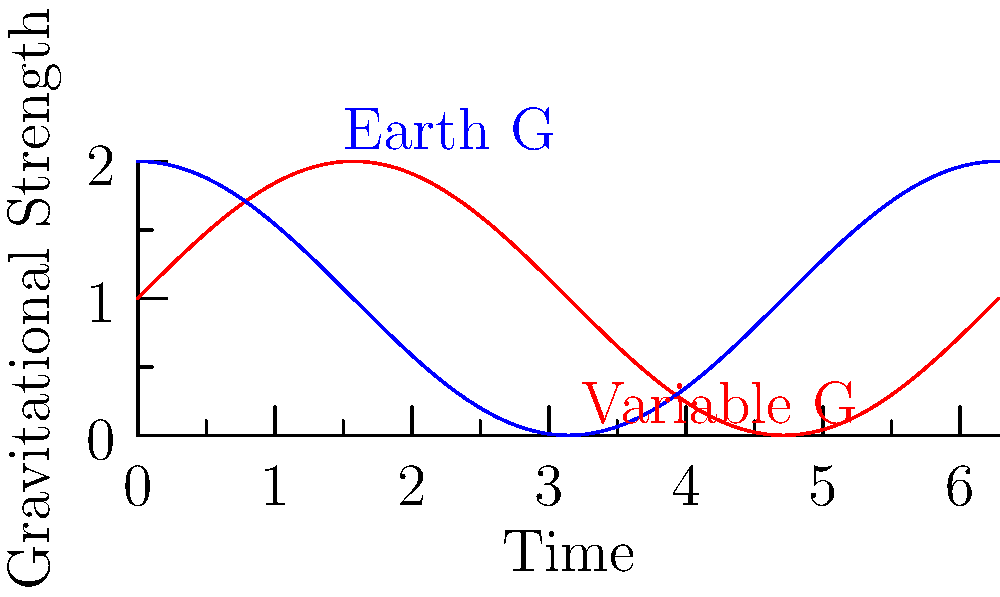In a time travel scenario, a scientist experiences varying gravitational fields as shown in the graph. How would the biomechanical adaptation of the time traveler's skeletal system differ between the variable G (red) and Earth G (blue) environments over time, and what potential issues might arise during the transition between these gravitational fields? 1. Gravitational variation: The red line shows a sinusoidal variation in gravitational strength, while the blue line represents constant Earth gravity.

2. Skeletal adaptation in variable G:
   a. Bone density: In periods of higher G, bone density would increase to withstand greater forces.
   b. Bone remodeling: Rapid changes in G would trigger accelerated bone remodeling.
   c. Muscle-bone interaction: Varying G would cause fluctuating muscle tension, affecting bone structure.

3. Skeletal adaptation in Earth G:
   a. Consistent bone density maintained.
   b. Normal bone remodeling rate.
   c. Stable muscle-bone interaction.

4. Transition issues:
   a. Bone fragility: Rapid transition from low to high G could lead to fractures.
   b. Muscle fatigue: Sudden increase in G would strain muscles accustomed to lower gravity.
   c. Balance and coordination: Vestibular system would need to readjust, causing disorientation.

5. Biomechanical principles:
   a. Wolff's Law: Bone adapts to loads placed upon it.
   b. Davis' Law: Soft tissue adapts to imposed demands.

6. Time factor:
   The frequency of gravitational changes would determine the body's ability to adapt. Rapid changes (high-frequency oscillations) would be more challenging than gradual changes.

7. Potential solutions:
   a. Gradual transition between gravitational fields.
   b. Protective exoskeletons to support the skeletal system during transitions.
   c. Pharmaceutical interventions to accelerate bone and muscle adaptation.
Answer: Variable G causes rapid bone remodeling and muscle-tension fluctuations, risking fractures and disorientation during transitions, while Earth G maintains stable skeletal conditions. 